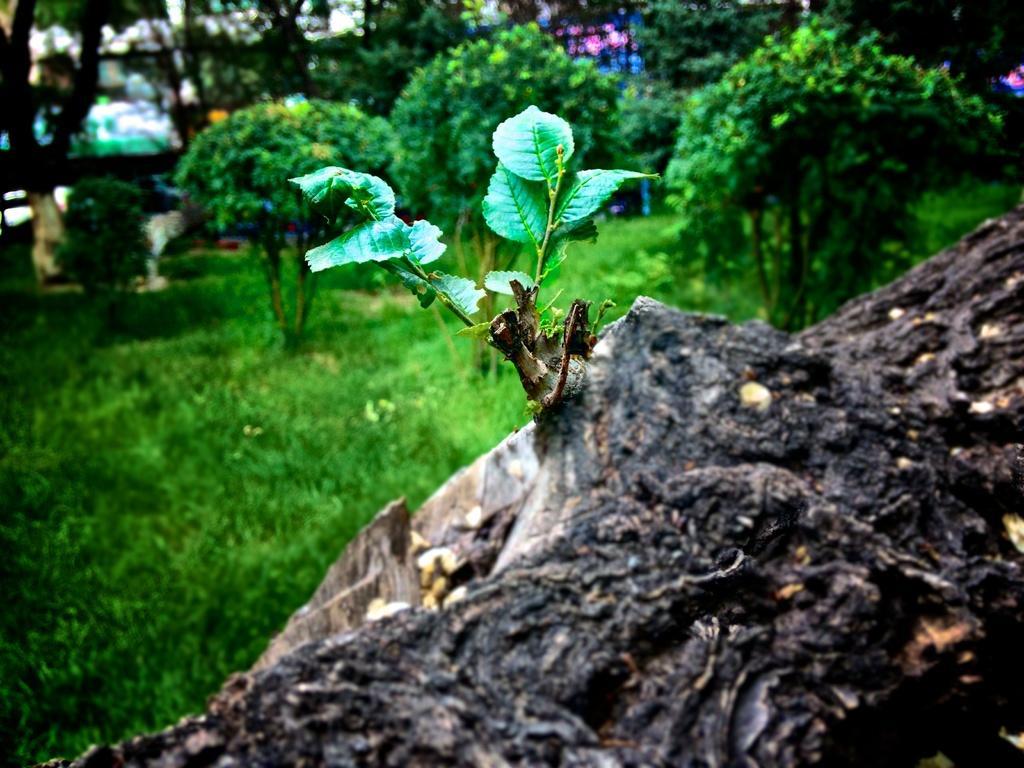In one or two sentences, can you explain what this image depicts? In this picture we can see a tree trunk, grass, plants on the ground and in the background we can see trees and some objects. 